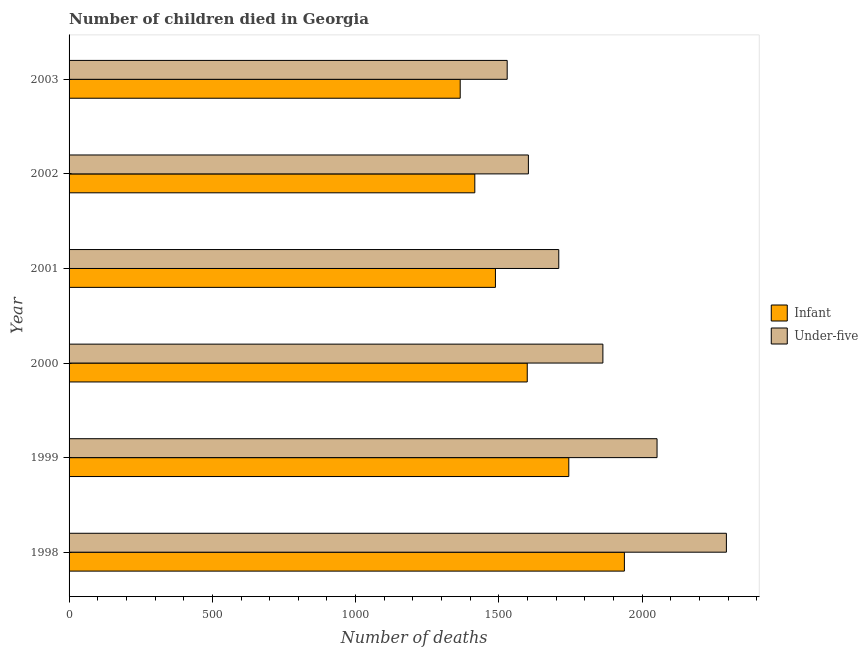How many different coloured bars are there?
Provide a short and direct response. 2. Are the number of bars per tick equal to the number of legend labels?
Provide a succinct answer. Yes. How many bars are there on the 6th tick from the top?
Offer a terse response. 2. How many bars are there on the 1st tick from the bottom?
Offer a terse response. 2. What is the label of the 4th group of bars from the top?
Provide a short and direct response. 2000. In how many cases, is the number of bars for a given year not equal to the number of legend labels?
Give a very brief answer. 0. What is the number of infant deaths in 2003?
Keep it short and to the point. 1365. Across all years, what is the maximum number of infant deaths?
Ensure brevity in your answer.  1938. Across all years, what is the minimum number of infant deaths?
Make the answer very short. 1365. In which year was the number of infant deaths maximum?
Your answer should be very brief. 1998. What is the total number of infant deaths in the graph?
Keep it short and to the point. 9550. What is the difference between the number of under-five deaths in 1998 and that in 2001?
Ensure brevity in your answer.  585. What is the difference between the number of infant deaths in 2002 and the number of under-five deaths in 2003?
Your answer should be very brief. -113. What is the average number of infant deaths per year?
Your answer should be very brief. 1591.67. In the year 1999, what is the difference between the number of under-five deaths and number of infant deaths?
Provide a short and direct response. 308. In how many years, is the number of infant deaths greater than 1700 ?
Keep it short and to the point. 2. What is the ratio of the number of infant deaths in 1999 to that in 2001?
Your answer should be very brief. 1.17. What is the difference between the highest and the second highest number of under-five deaths?
Your response must be concise. 242. What is the difference between the highest and the lowest number of under-five deaths?
Ensure brevity in your answer.  765. Is the sum of the number of infant deaths in 1998 and 2003 greater than the maximum number of under-five deaths across all years?
Your response must be concise. Yes. What does the 1st bar from the top in 1998 represents?
Make the answer very short. Under-five. What does the 1st bar from the bottom in 1999 represents?
Provide a succinct answer. Infant. Are all the bars in the graph horizontal?
Provide a succinct answer. Yes. How many years are there in the graph?
Ensure brevity in your answer.  6. What is the difference between two consecutive major ticks on the X-axis?
Your answer should be compact. 500. Does the graph contain grids?
Your response must be concise. No. What is the title of the graph?
Ensure brevity in your answer.  Number of children died in Georgia. Does "US$" appear as one of the legend labels in the graph?
Your answer should be compact. No. What is the label or title of the X-axis?
Give a very brief answer. Number of deaths. What is the Number of deaths of Infant in 1998?
Provide a succinct answer. 1938. What is the Number of deaths in Under-five in 1998?
Keep it short and to the point. 2294. What is the Number of deaths in Infant in 1999?
Make the answer very short. 1744. What is the Number of deaths of Under-five in 1999?
Your answer should be very brief. 2052. What is the Number of deaths in Infant in 2000?
Provide a succinct answer. 1599. What is the Number of deaths in Under-five in 2000?
Ensure brevity in your answer.  1863. What is the Number of deaths in Infant in 2001?
Your answer should be very brief. 1488. What is the Number of deaths in Under-five in 2001?
Your response must be concise. 1709. What is the Number of deaths in Infant in 2002?
Your response must be concise. 1416. What is the Number of deaths in Under-five in 2002?
Provide a short and direct response. 1603. What is the Number of deaths in Infant in 2003?
Your answer should be compact. 1365. What is the Number of deaths in Under-five in 2003?
Provide a short and direct response. 1529. Across all years, what is the maximum Number of deaths of Infant?
Provide a succinct answer. 1938. Across all years, what is the maximum Number of deaths of Under-five?
Provide a short and direct response. 2294. Across all years, what is the minimum Number of deaths in Infant?
Provide a short and direct response. 1365. Across all years, what is the minimum Number of deaths of Under-five?
Provide a succinct answer. 1529. What is the total Number of deaths of Infant in the graph?
Your response must be concise. 9550. What is the total Number of deaths in Under-five in the graph?
Offer a terse response. 1.10e+04. What is the difference between the Number of deaths of Infant in 1998 and that in 1999?
Give a very brief answer. 194. What is the difference between the Number of deaths of Under-five in 1998 and that in 1999?
Make the answer very short. 242. What is the difference between the Number of deaths in Infant in 1998 and that in 2000?
Provide a succinct answer. 339. What is the difference between the Number of deaths of Under-five in 1998 and that in 2000?
Ensure brevity in your answer.  431. What is the difference between the Number of deaths of Infant in 1998 and that in 2001?
Your answer should be very brief. 450. What is the difference between the Number of deaths in Under-five in 1998 and that in 2001?
Your answer should be very brief. 585. What is the difference between the Number of deaths in Infant in 1998 and that in 2002?
Your answer should be very brief. 522. What is the difference between the Number of deaths in Under-five in 1998 and that in 2002?
Provide a succinct answer. 691. What is the difference between the Number of deaths in Infant in 1998 and that in 2003?
Your answer should be very brief. 573. What is the difference between the Number of deaths in Under-five in 1998 and that in 2003?
Give a very brief answer. 765. What is the difference between the Number of deaths in Infant in 1999 and that in 2000?
Your answer should be very brief. 145. What is the difference between the Number of deaths of Under-five in 1999 and that in 2000?
Keep it short and to the point. 189. What is the difference between the Number of deaths of Infant in 1999 and that in 2001?
Offer a terse response. 256. What is the difference between the Number of deaths in Under-five in 1999 and that in 2001?
Your response must be concise. 343. What is the difference between the Number of deaths of Infant in 1999 and that in 2002?
Your answer should be very brief. 328. What is the difference between the Number of deaths in Under-five in 1999 and that in 2002?
Ensure brevity in your answer.  449. What is the difference between the Number of deaths of Infant in 1999 and that in 2003?
Your response must be concise. 379. What is the difference between the Number of deaths in Under-five in 1999 and that in 2003?
Give a very brief answer. 523. What is the difference between the Number of deaths of Infant in 2000 and that in 2001?
Provide a short and direct response. 111. What is the difference between the Number of deaths of Under-five in 2000 and that in 2001?
Provide a succinct answer. 154. What is the difference between the Number of deaths of Infant in 2000 and that in 2002?
Give a very brief answer. 183. What is the difference between the Number of deaths in Under-five in 2000 and that in 2002?
Give a very brief answer. 260. What is the difference between the Number of deaths in Infant in 2000 and that in 2003?
Offer a terse response. 234. What is the difference between the Number of deaths in Under-five in 2000 and that in 2003?
Your answer should be very brief. 334. What is the difference between the Number of deaths of Under-five in 2001 and that in 2002?
Your response must be concise. 106. What is the difference between the Number of deaths in Infant in 2001 and that in 2003?
Your response must be concise. 123. What is the difference between the Number of deaths of Under-five in 2001 and that in 2003?
Offer a terse response. 180. What is the difference between the Number of deaths of Infant in 1998 and the Number of deaths of Under-five in 1999?
Provide a succinct answer. -114. What is the difference between the Number of deaths of Infant in 1998 and the Number of deaths of Under-five in 2001?
Offer a very short reply. 229. What is the difference between the Number of deaths of Infant in 1998 and the Number of deaths of Under-five in 2002?
Provide a succinct answer. 335. What is the difference between the Number of deaths in Infant in 1998 and the Number of deaths in Under-five in 2003?
Provide a short and direct response. 409. What is the difference between the Number of deaths in Infant in 1999 and the Number of deaths in Under-five in 2000?
Make the answer very short. -119. What is the difference between the Number of deaths of Infant in 1999 and the Number of deaths of Under-five in 2001?
Keep it short and to the point. 35. What is the difference between the Number of deaths of Infant in 1999 and the Number of deaths of Under-five in 2002?
Your answer should be very brief. 141. What is the difference between the Number of deaths of Infant in 1999 and the Number of deaths of Under-five in 2003?
Give a very brief answer. 215. What is the difference between the Number of deaths in Infant in 2000 and the Number of deaths in Under-five in 2001?
Your answer should be very brief. -110. What is the difference between the Number of deaths of Infant in 2001 and the Number of deaths of Under-five in 2002?
Keep it short and to the point. -115. What is the difference between the Number of deaths in Infant in 2001 and the Number of deaths in Under-five in 2003?
Your response must be concise. -41. What is the difference between the Number of deaths of Infant in 2002 and the Number of deaths of Under-five in 2003?
Your response must be concise. -113. What is the average Number of deaths of Infant per year?
Make the answer very short. 1591.67. What is the average Number of deaths of Under-five per year?
Provide a succinct answer. 1841.67. In the year 1998, what is the difference between the Number of deaths in Infant and Number of deaths in Under-five?
Ensure brevity in your answer.  -356. In the year 1999, what is the difference between the Number of deaths in Infant and Number of deaths in Under-five?
Your answer should be very brief. -308. In the year 2000, what is the difference between the Number of deaths of Infant and Number of deaths of Under-five?
Provide a succinct answer. -264. In the year 2001, what is the difference between the Number of deaths in Infant and Number of deaths in Under-five?
Ensure brevity in your answer.  -221. In the year 2002, what is the difference between the Number of deaths in Infant and Number of deaths in Under-five?
Ensure brevity in your answer.  -187. In the year 2003, what is the difference between the Number of deaths in Infant and Number of deaths in Under-five?
Provide a succinct answer. -164. What is the ratio of the Number of deaths of Infant in 1998 to that in 1999?
Your answer should be very brief. 1.11. What is the ratio of the Number of deaths in Under-five in 1998 to that in 1999?
Your answer should be very brief. 1.12. What is the ratio of the Number of deaths in Infant in 1998 to that in 2000?
Give a very brief answer. 1.21. What is the ratio of the Number of deaths of Under-five in 1998 to that in 2000?
Your answer should be compact. 1.23. What is the ratio of the Number of deaths in Infant in 1998 to that in 2001?
Your answer should be very brief. 1.3. What is the ratio of the Number of deaths in Under-five in 1998 to that in 2001?
Ensure brevity in your answer.  1.34. What is the ratio of the Number of deaths in Infant in 1998 to that in 2002?
Give a very brief answer. 1.37. What is the ratio of the Number of deaths of Under-five in 1998 to that in 2002?
Ensure brevity in your answer.  1.43. What is the ratio of the Number of deaths of Infant in 1998 to that in 2003?
Provide a succinct answer. 1.42. What is the ratio of the Number of deaths of Under-five in 1998 to that in 2003?
Your answer should be compact. 1.5. What is the ratio of the Number of deaths in Infant in 1999 to that in 2000?
Give a very brief answer. 1.09. What is the ratio of the Number of deaths of Under-five in 1999 to that in 2000?
Offer a terse response. 1.1. What is the ratio of the Number of deaths in Infant in 1999 to that in 2001?
Your answer should be very brief. 1.17. What is the ratio of the Number of deaths in Under-five in 1999 to that in 2001?
Ensure brevity in your answer.  1.2. What is the ratio of the Number of deaths in Infant in 1999 to that in 2002?
Offer a terse response. 1.23. What is the ratio of the Number of deaths in Under-five in 1999 to that in 2002?
Offer a terse response. 1.28. What is the ratio of the Number of deaths of Infant in 1999 to that in 2003?
Offer a very short reply. 1.28. What is the ratio of the Number of deaths of Under-five in 1999 to that in 2003?
Provide a succinct answer. 1.34. What is the ratio of the Number of deaths in Infant in 2000 to that in 2001?
Provide a succinct answer. 1.07. What is the ratio of the Number of deaths of Under-five in 2000 to that in 2001?
Keep it short and to the point. 1.09. What is the ratio of the Number of deaths of Infant in 2000 to that in 2002?
Your response must be concise. 1.13. What is the ratio of the Number of deaths of Under-five in 2000 to that in 2002?
Your answer should be very brief. 1.16. What is the ratio of the Number of deaths in Infant in 2000 to that in 2003?
Your answer should be compact. 1.17. What is the ratio of the Number of deaths in Under-five in 2000 to that in 2003?
Your answer should be compact. 1.22. What is the ratio of the Number of deaths of Infant in 2001 to that in 2002?
Keep it short and to the point. 1.05. What is the ratio of the Number of deaths in Under-five in 2001 to that in 2002?
Keep it short and to the point. 1.07. What is the ratio of the Number of deaths of Infant in 2001 to that in 2003?
Your answer should be very brief. 1.09. What is the ratio of the Number of deaths in Under-five in 2001 to that in 2003?
Your answer should be compact. 1.12. What is the ratio of the Number of deaths of Infant in 2002 to that in 2003?
Ensure brevity in your answer.  1.04. What is the ratio of the Number of deaths of Under-five in 2002 to that in 2003?
Provide a short and direct response. 1.05. What is the difference between the highest and the second highest Number of deaths of Infant?
Make the answer very short. 194. What is the difference between the highest and the second highest Number of deaths of Under-five?
Provide a short and direct response. 242. What is the difference between the highest and the lowest Number of deaths in Infant?
Your answer should be very brief. 573. What is the difference between the highest and the lowest Number of deaths of Under-five?
Ensure brevity in your answer.  765. 